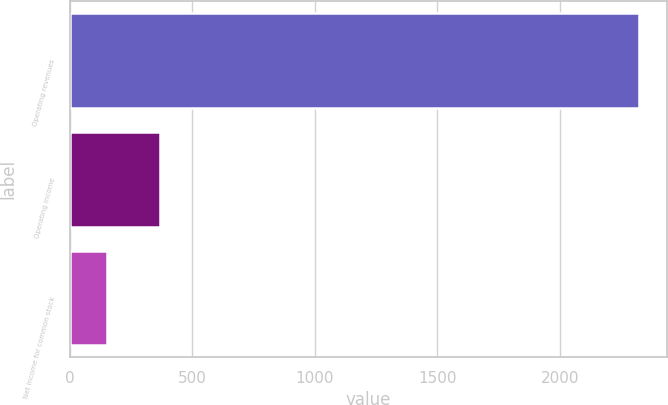<chart> <loc_0><loc_0><loc_500><loc_500><bar_chart><fcel>Operating revenues<fcel>Operating income<fcel>Net income for common stock<nl><fcel>2321<fcel>369.8<fcel>153<nl></chart> 